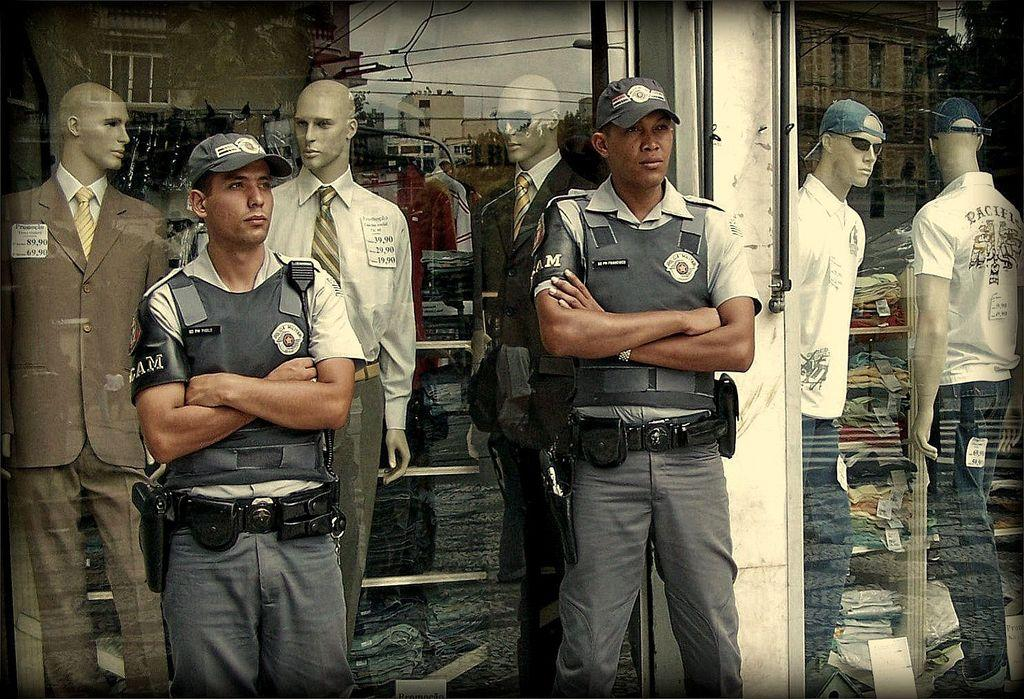How many people are present in the image? There are two men in the image. What else can be seen in the image besides the men? There are clothes and mannequins in the image. What is unique about the image? The image contains a mirror reflection. What can be seen in the mirror reflection? In the mirror reflection, there are buildings and trees visible. What type of insurance policy is being discussed by the men in the image? There is no indication in the image that the men are discussing any insurance policies. 